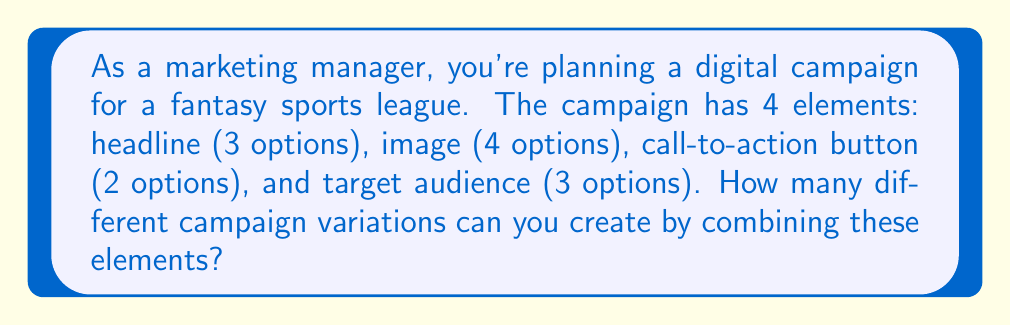Help me with this question. Let's approach this step-by-step using the multiplication principle:

1) We have 4 independent elements, each with its own number of options:
   - Headlines: 3 options
   - Images: 4 options
   - Call-to-action buttons: 2 options
   - Target audiences: 3 options

2) For each campaign variation, we need to choose one option from each element.

3) The multiplication principle states that if we have a series of independent choices, the total number of possible outcomes is the product of the number of possibilities for each choice.

4) Therefore, we multiply the number of options for each element:

   $$ \text{Total variations} = 3 \times 4 \times 2 \times 3 $$

5) Calculating this:
   $$ 3 \times 4 = 12 $$
   $$ 12 \times 2 = 24 $$
   $$ 24 \times 3 = 72 $$

Thus, there are 72 possible campaign variations.
Answer: 72 